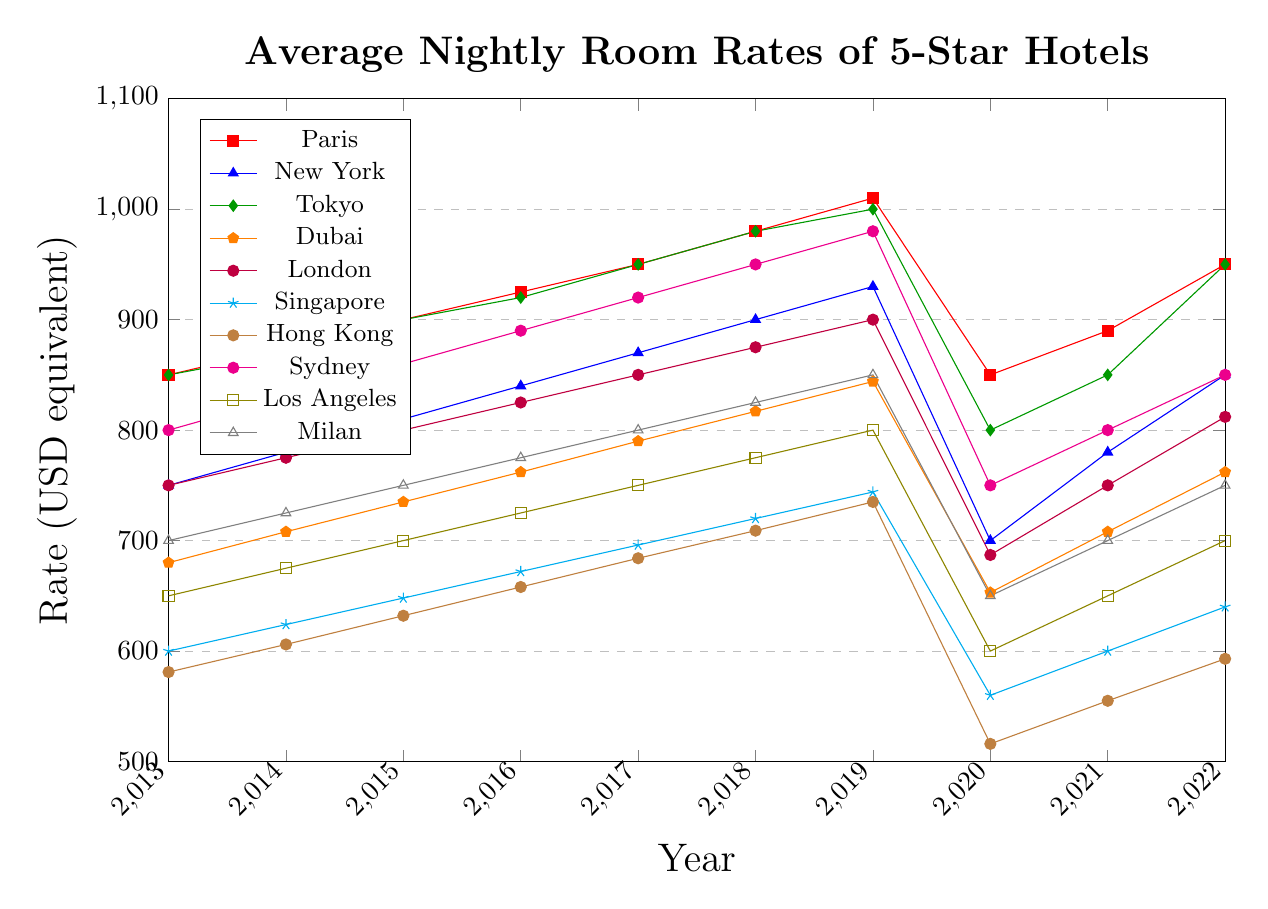Which city had the highest average nightly room rate in 2019? Identify the highest point in the 2019 data from all the plotted lines. The highest rate in 2019 is for Paris with €1010.
Answer: Paris How did the average nightly room rate in New York change from 2020 to 2022? Look at the line for New York and observe the values for 2020, 2021, and 2022. The values are $700, $780, and $850, respectively. Thus, the rate increased from 2020 to 2022.
Answer: Increased Which two cities had the most similar trends in average nightly room rate over the decade? Compare the shapes of the lines for each city over the decade. Paris and Tokyo both show similar upward trends and significant drops in 2020.
Answer: Paris and Tokyo What is the average room rate for Sydney across the ten-year period? Sum the values for Sydney from 2013 to 2022 (800 + 830 + 860 + 890 + 920 + 950 + 980 + 750 + 800 + 850) and divide by 10. The sum is 8630, thus the average is 8630 / 10.
Answer: 863 During which year did London and Los Angeles have the same average nightly room rate? Look for the point where the lines for London and Los Angeles intersect. Both cities had a rate of $650 in 2020.
Answer: 2020 Which city experienced the largest drop in average nightly room rate in 2020? Calculate the difference between 2019 and 2020 for each city and identify the largest drop. Hong Kong had the largest drop from HKD 5700 in 2019 to HKD 4000 in 2020, a drop of HKD 1700.
Answer: Hong Kong What was the average increase in nightly room rate for Milan from 2013 to 2019? Calculate the difference between 2019 and 2013 (850 - 700 = 150). To find the average increase per year over 6 years, divide 150 by 6, giving an average yearly increase of 25.
Answer: 25 By how much did the average nightly room rate in Dubai change from 2013 to 2018? Calculate the difference between the rates for Dubai in 2018 and 2013 (817 AED - 680 AED). The difference is 137 AED.
Answer: 137 AED Is the 2022 rate for Singapore higher or lower than its 2018 rate? Compare the values for Singapore in 2018 and 2022. In 2018, it was 720, and in 2022 it was 640. Thus, the 2022 rate is lower.
Answer: Lower 